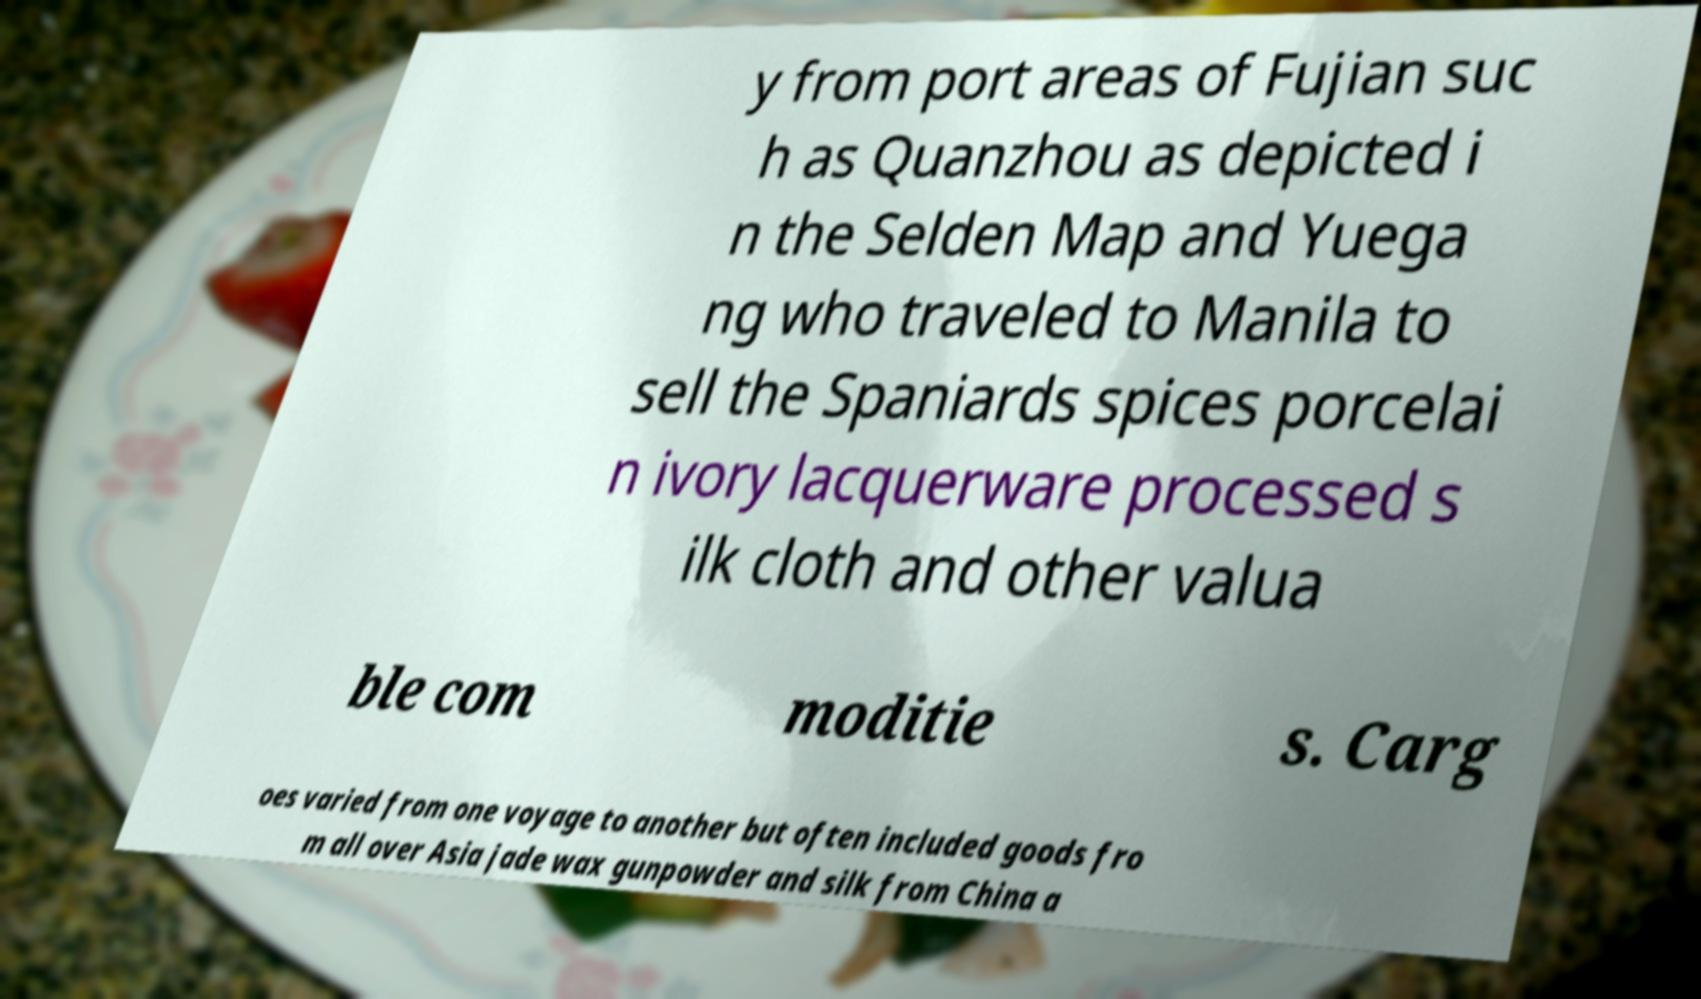What messages or text are displayed in this image? I need them in a readable, typed format. y from port areas of Fujian suc h as Quanzhou as depicted i n the Selden Map and Yuega ng who traveled to Manila to sell the Spaniards spices porcelai n ivory lacquerware processed s ilk cloth and other valua ble com moditie s. Carg oes varied from one voyage to another but often included goods fro m all over Asia jade wax gunpowder and silk from China a 